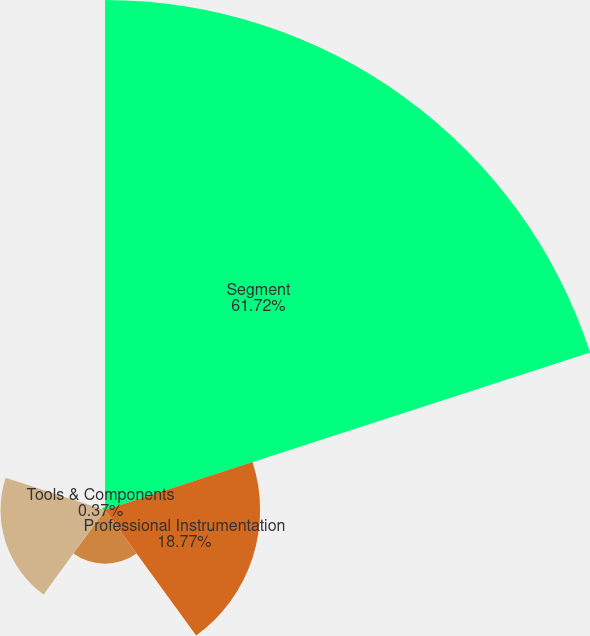Convert chart to OTSL. <chart><loc_0><loc_0><loc_500><loc_500><pie_chart><fcel>Segment<fcel>Professional Instrumentation<fcel>Medical Technologies<fcel>Industrial Technologies<fcel>Tools & Components<nl><fcel>61.72%<fcel>18.77%<fcel>6.5%<fcel>12.64%<fcel>0.37%<nl></chart> 